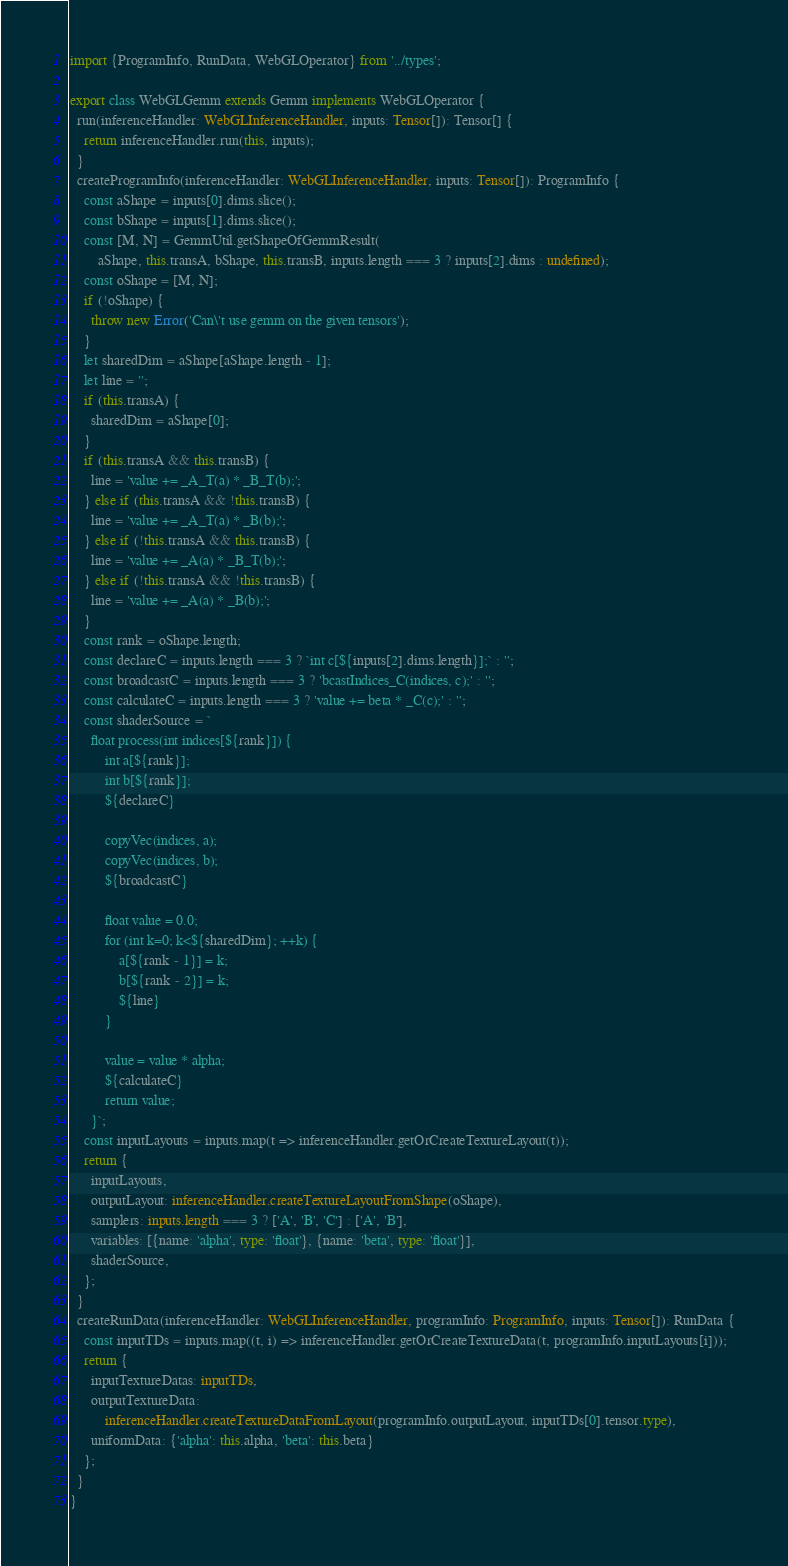<code> <loc_0><loc_0><loc_500><loc_500><_TypeScript_>import {ProgramInfo, RunData, WebGLOperator} from '../types';

export class WebGLGemm extends Gemm implements WebGLOperator {
  run(inferenceHandler: WebGLInferenceHandler, inputs: Tensor[]): Tensor[] {
    return inferenceHandler.run(this, inputs);
  }
  createProgramInfo(inferenceHandler: WebGLInferenceHandler, inputs: Tensor[]): ProgramInfo {
    const aShape = inputs[0].dims.slice();
    const bShape = inputs[1].dims.slice();
    const [M, N] = GemmUtil.getShapeOfGemmResult(
        aShape, this.transA, bShape, this.transB, inputs.length === 3 ? inputs[2].dims : undefined);
    const oShape = [M, N];
    if (!oShape) {
      throw new Error('Can\'t use gemm on the given tensors');
    }
    let sharedDim = aShape[aShape.length - 1];
    let line = '';
    if (this.transA) {
      sharedDim = aShape[0];
    }
    if (this.transA && this.transB) {
      line = 'value += _A_T(a) * _B_T(b);';
    } else if (this.transA && !this.transB) {
      line = 'value += _A_T(a) * _B(b);';
    } else if (!this.transA && this.transB) {
      line = 'value += _A(a) * _B_T(b);';
    } else if (!this.transA && !this.transB) {
      line = 'value += _A(a) * _B(b);';
    }
    const rank = oShape.length;
    const declareC = inputs.length === 3 ? `int c[${inputs[2].dims.length}];` : '';
    const broadcastC = inputs.length === 3 ? 'bcastIndices_C(indices, c);' : '';
    const calculateC = inputs.length === 3 ? 'value += beta * _C(c);' : '';
    const shaderSource = `
      float process(int indices[${rank}]) {
          int a[${rank}];
          int b[${rank}];
          ${declareC}

          copyVec(indices, a);
          copyVec(indices, b);
          ${broadcastC}

          float value = 0.0;
          for (int k=0; k<${sharedDim}; ++k) {
              a[${rank - 1}] = k;
              b[${rank - 2}] = k;
              ${line}
          }

          value = value * alpha;
          ${calculateC}
          return value;
      }`;
    const inputLayouts = inputs.map(t => inferenceHandler.getOrCreateTextureLayout(t));
    return {
      inputLayouts,
      outputLayout: inferenceHandler.createTextureLayoutFromShape(oShape),
      samplers: inputs.length === 3 ? ['A', 'B', 'C'] : ['A', 'B'],
      variables: [{name: 'alpha', type: 'float'}, {name: 'beta', type: 'float'}],
      shaderSource,
    };
  }
  createRunData(inferenceHandler: WebGLInferenceHandler, programInfo: ProgramInfo, inputs: Tensor[]): RunData {
    const inputTDs = inputs.map((t, i) => inferenceHandler.getOrCreateTextureData(t, programInfo.inputLayouts[i]));
    return {
      inputTextureDatas: inputTDs,
      outputTextureData:
          inferenceHandler.createTextureDataFromLayout(programInfo.outputLayout, inputTDs[0].tensor.type),
      uniformData: {'alpha': this.alpha, 'beta': this.beta}
    };
  }
}
</code> 